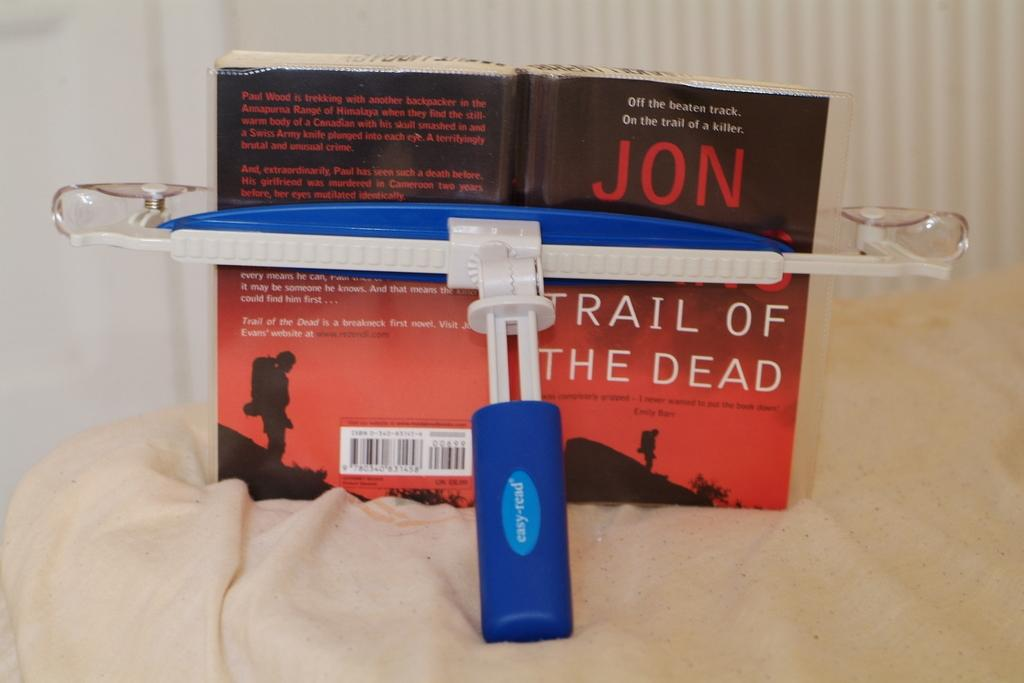Provide a one-sentence caption for the provided image. A book light and book entitled Jon Trail of the Dead. 